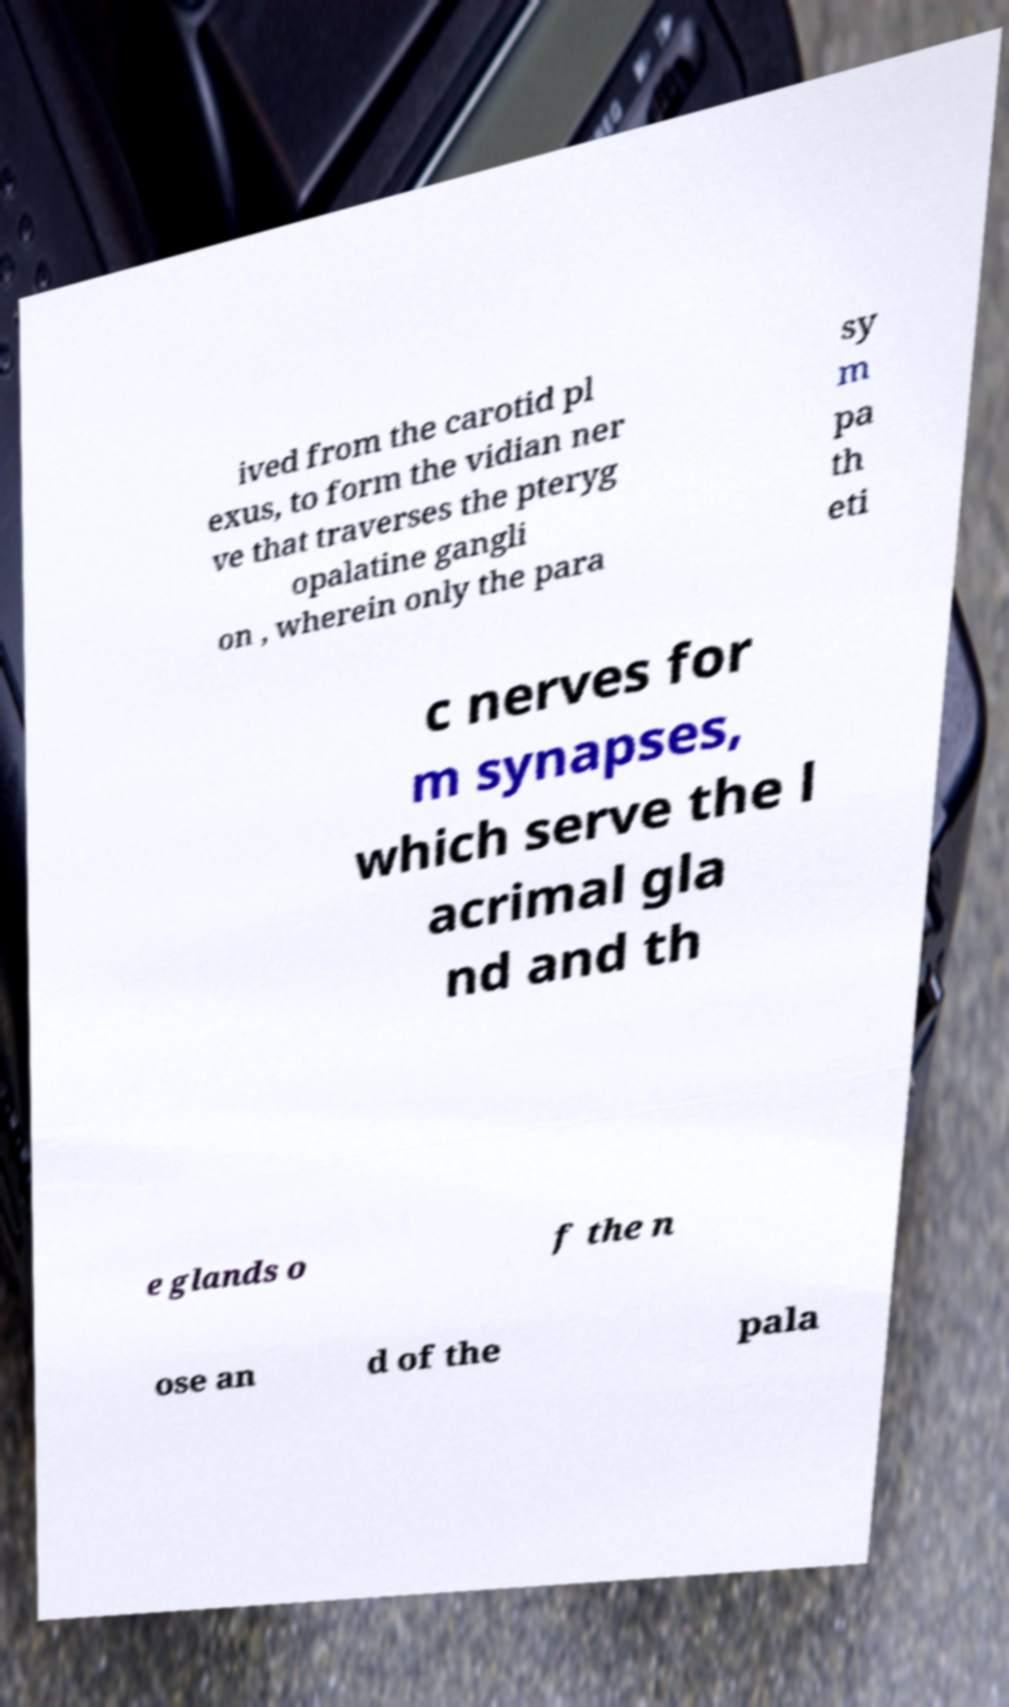Could you extract and type out the text from this image? ived from the carotid pl exus, to form the vidian ner ve that traverses the pteryg opalatine gangli on , wherein only the para sy m pa th eti c nerves for m synapses, which serve the l acrimal gla nd and th e glands o f the n ose an d of the pala 